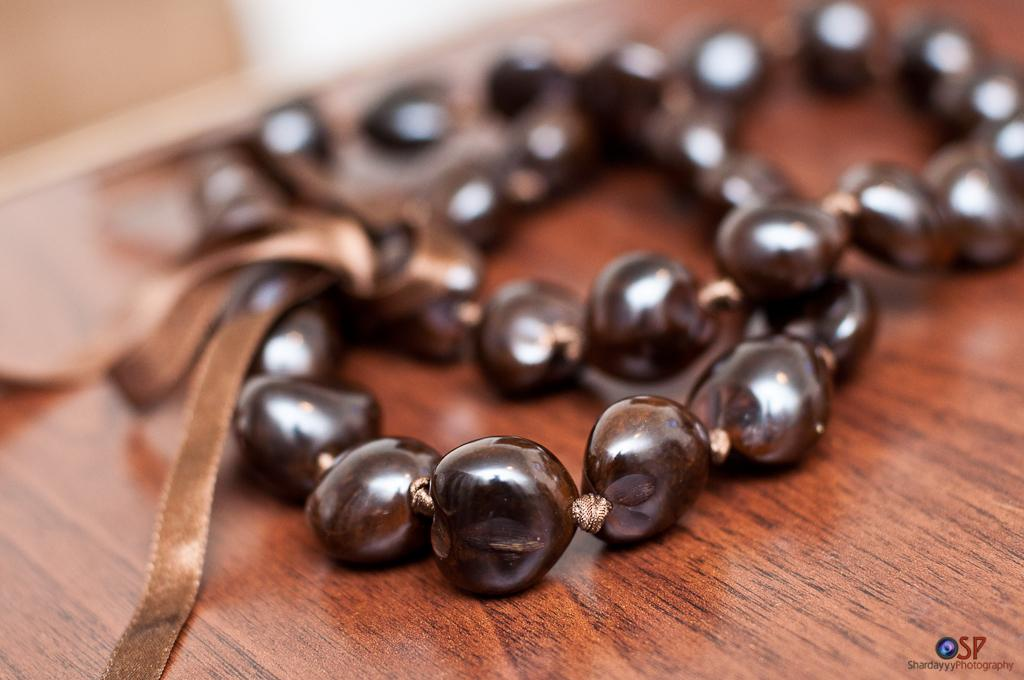What is the main object in the image? There is a beads chain in the image. Where is the beads chain placed? The beads chain is on a wooden platform. Is there any additional feature in the image? Yes, there is a watermark in the image. What type of pet can be seen playing with the beads chain in the image? There is no pet present in the image, and the beads chain is not being played with. 